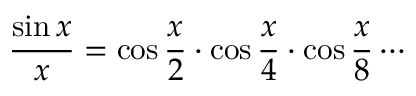<formula> <loc_0><loc_0><loc_500><loc_500>{ \frac { \sin x } { x } } = \cos { \frac { x } { 2 } } \cdot \cos { \frac { x } { 4 } } \cdot \cos { \frac { x } { 8 } } \cdots</formula> 